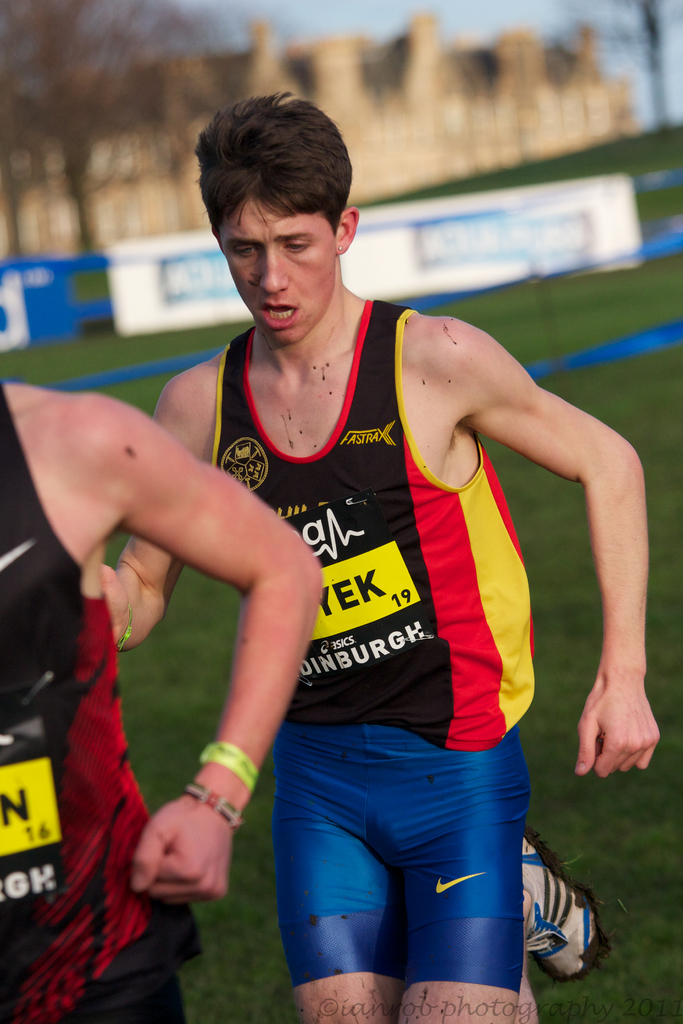What emotions does the athlete in the image seem to be experiencing, and how can you tell? The athlete appears to be experiencing intense exhaustion and determination. This is evident from his strained expression, slightly open mouth suggesting heavy breathing, and focused gaze forward, all indicating his effort and concentration during the race. 